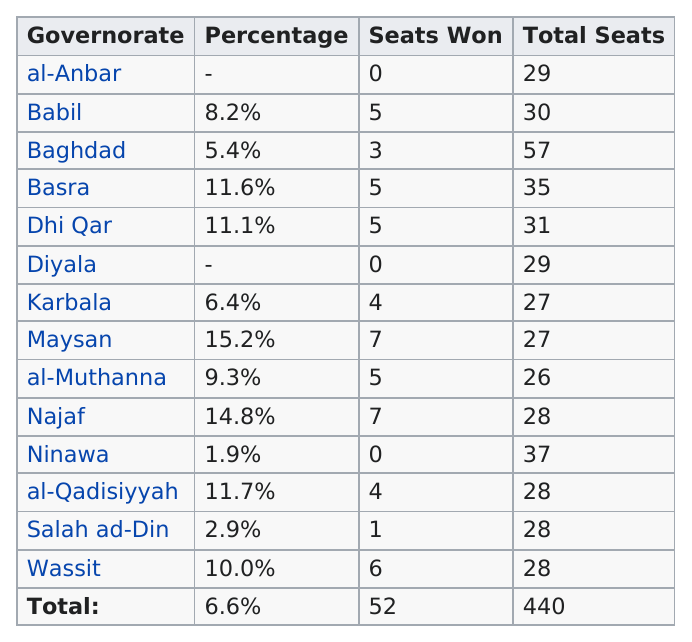Give some essential details in this illustration. Several provinces, including Basra, Dhi Qar, Maysan, al-Muthanna, Najaf, al-Qadisiyyah, and Wassit, had more than 9% of the vote in the recent provincial elections. The group with the most seats won in Baghdad is... Of the groups with a total of more than 32 seats, how many have more than 32 total seats? 